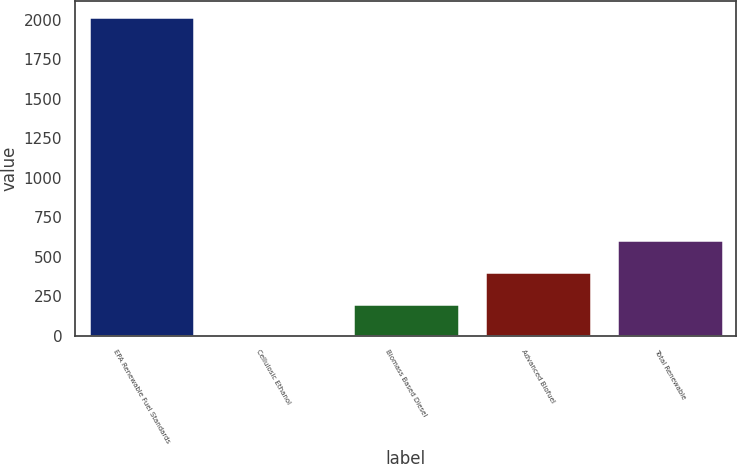<chart> <loc_0><loc_0><loc_500><loc_500><bar_chart><fcel>EPA Renewable Fuel Standards<fcel>Cellulosic Ethanol<fcel>Biomass Based Diesel<fcel>Advanced Biofuel<fcel>Total Renewable<nl><fcel>2016<fcel>0.23<fcel>201.81<fcel>403.39<fcel>604.97<nl></chart> 